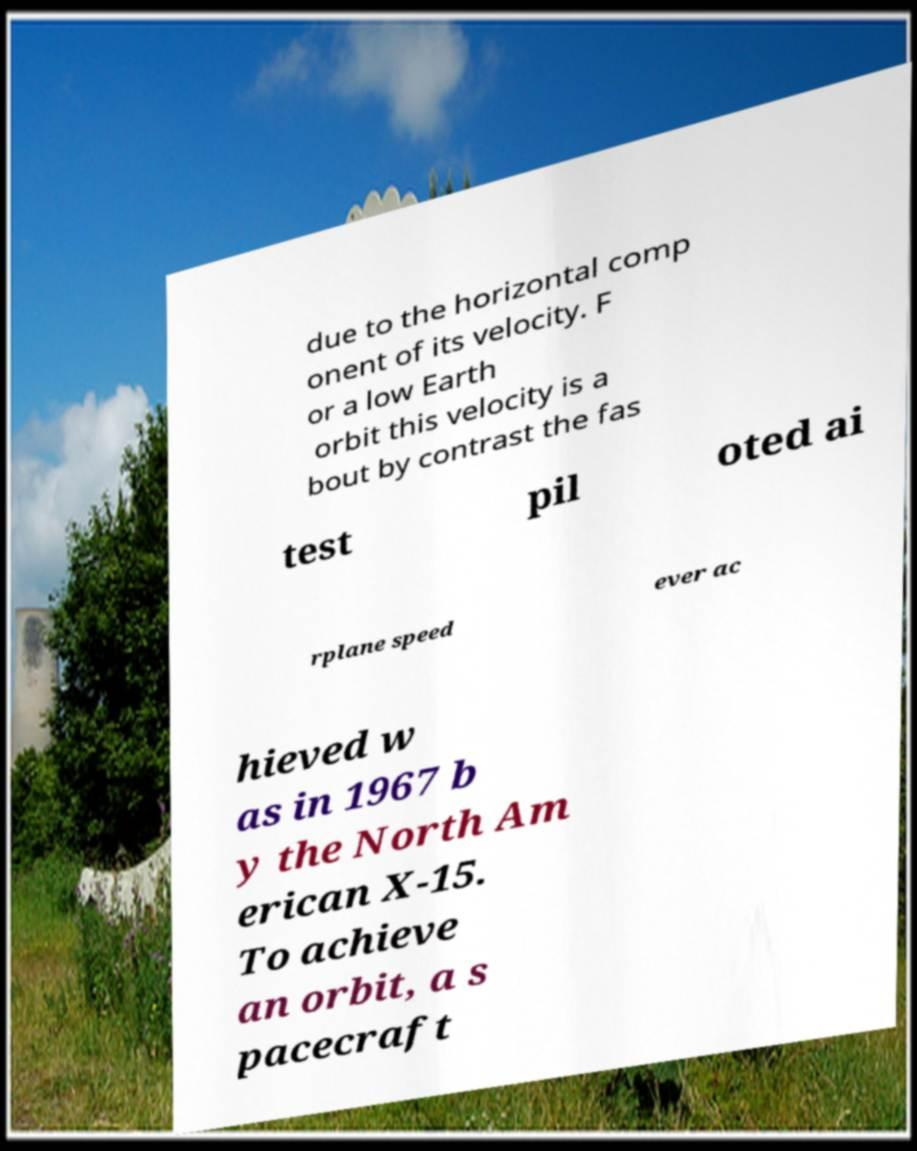What messages or text are displayed in this image? I need them in a readable, typed format. due to the horizontal comp onent of its velocity. F or a low Earth orbit this velocity is a bout by contrast the fas test pil oted ai rplane speed ever ac hieved w as in 1967 b y the North Am erican X-15. To achieve an orbit, a s pacecraft 